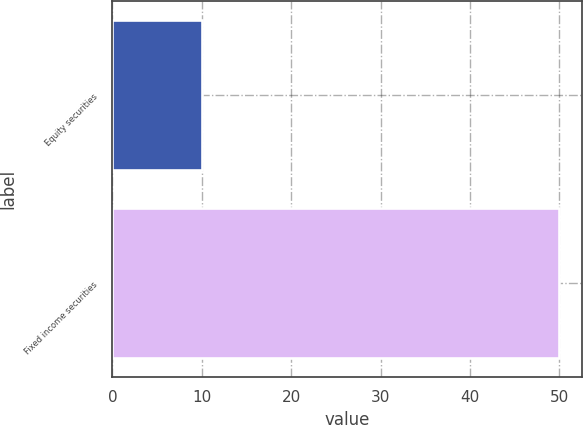<chart> <loc_0><loc_0><loc_500><loc_500><bar_chart><fcel>Equity securities<fcel>Fixed income securities<nl><fcel>10<fcel>50<nl></chart> 